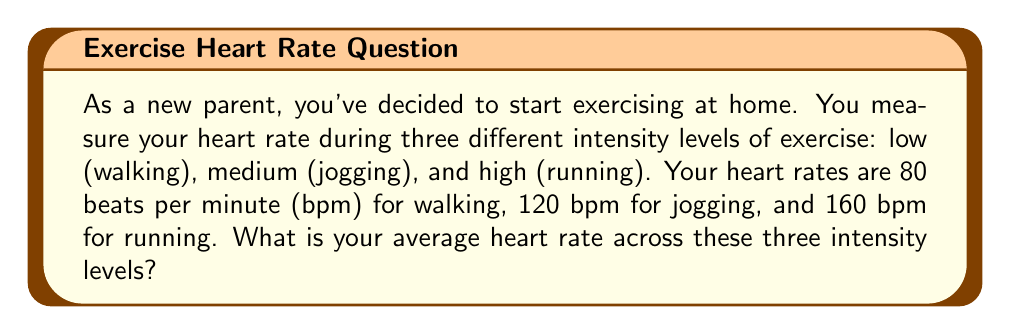Solve this math problem. Let's solve this step-by-step:

1. Identify the given heart rates:
   - Low intensity (walking): 80 bpm
   - Medium intensity (jogging): 120 bpm
   - High intensity (running): 160 bpm

2. To calculate the average, we need to:
   a) Add up all the values
   b) Divide by the number of values

3. Add up all the heart rates:
   $$ 80 + 120 + 160 = 360 \text{ bpm} $$

4. Count the number of intensity levels:
   There are 3 intensity levels (low, medium, high)

5. Calculate the average by dividing the sum by the number of intensity levels:
   $$ \text{Average} = \frac{\text{Sum of heart rates}}{\text{Number of intensity levels}} $$
   $$ \text{Average} = \frac{360}{3} = 120 \text{ bpm} $$

Therefore, your average heart rate across the three intensity levels is 120 bpm.
Answer: 120 bpm 